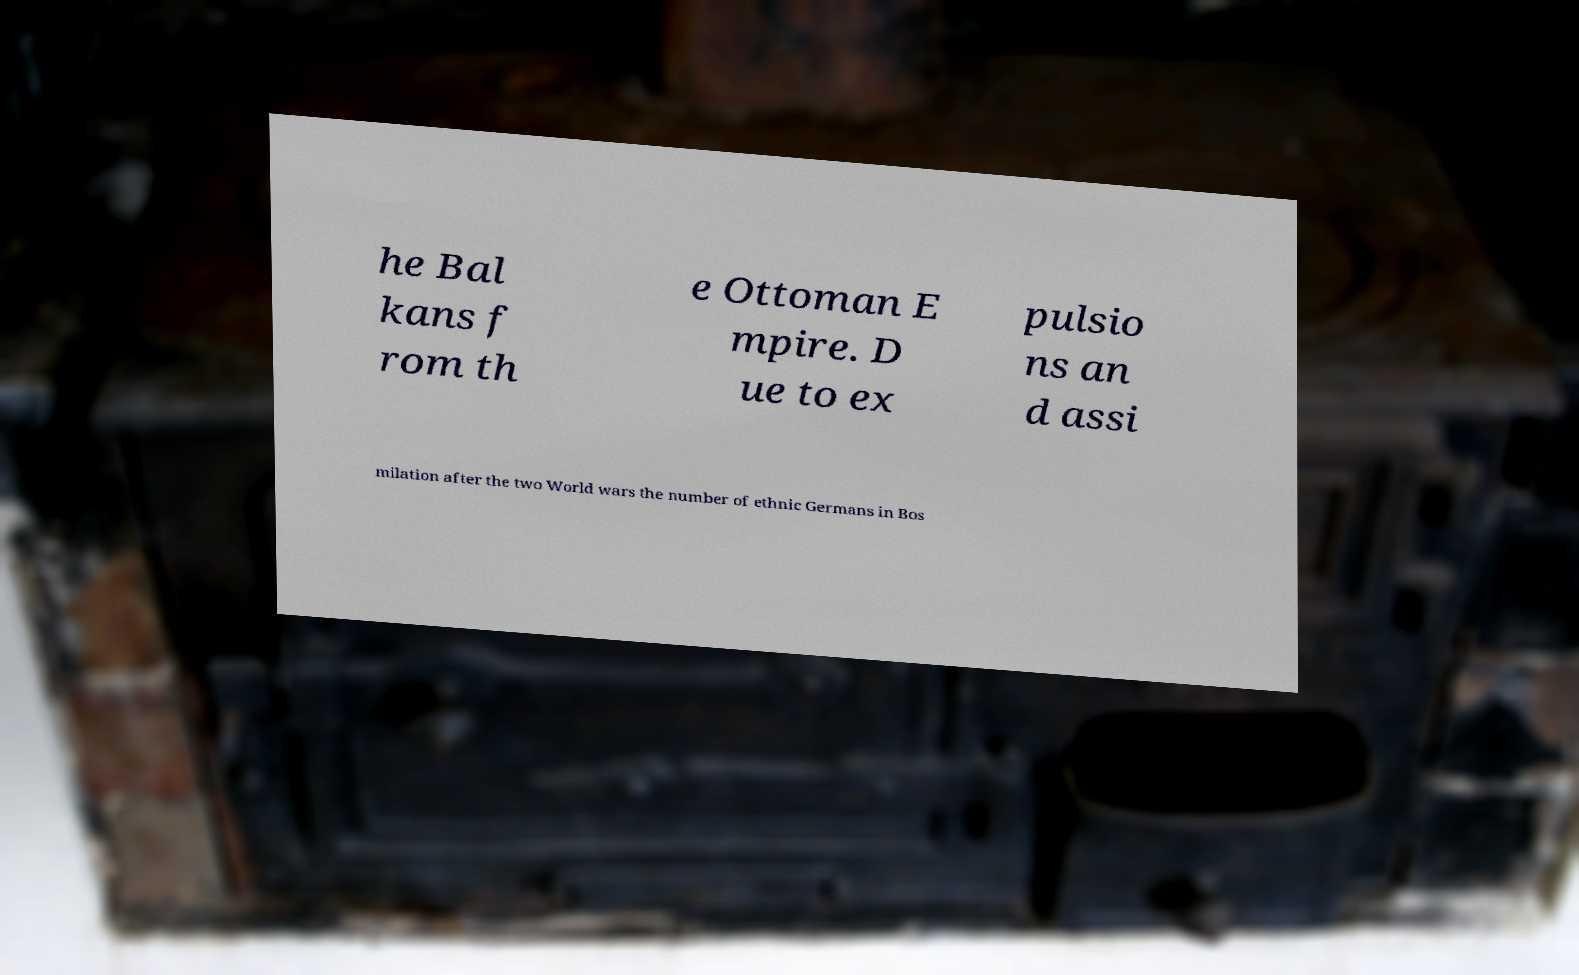I need the written content from this picture converted into text. Can you do that? he Bal kans f rom th e Ottoman E mpire. D ue to ex pulsio ns an d assi milation after the two World wars the number of ethnic Germans in Bos 